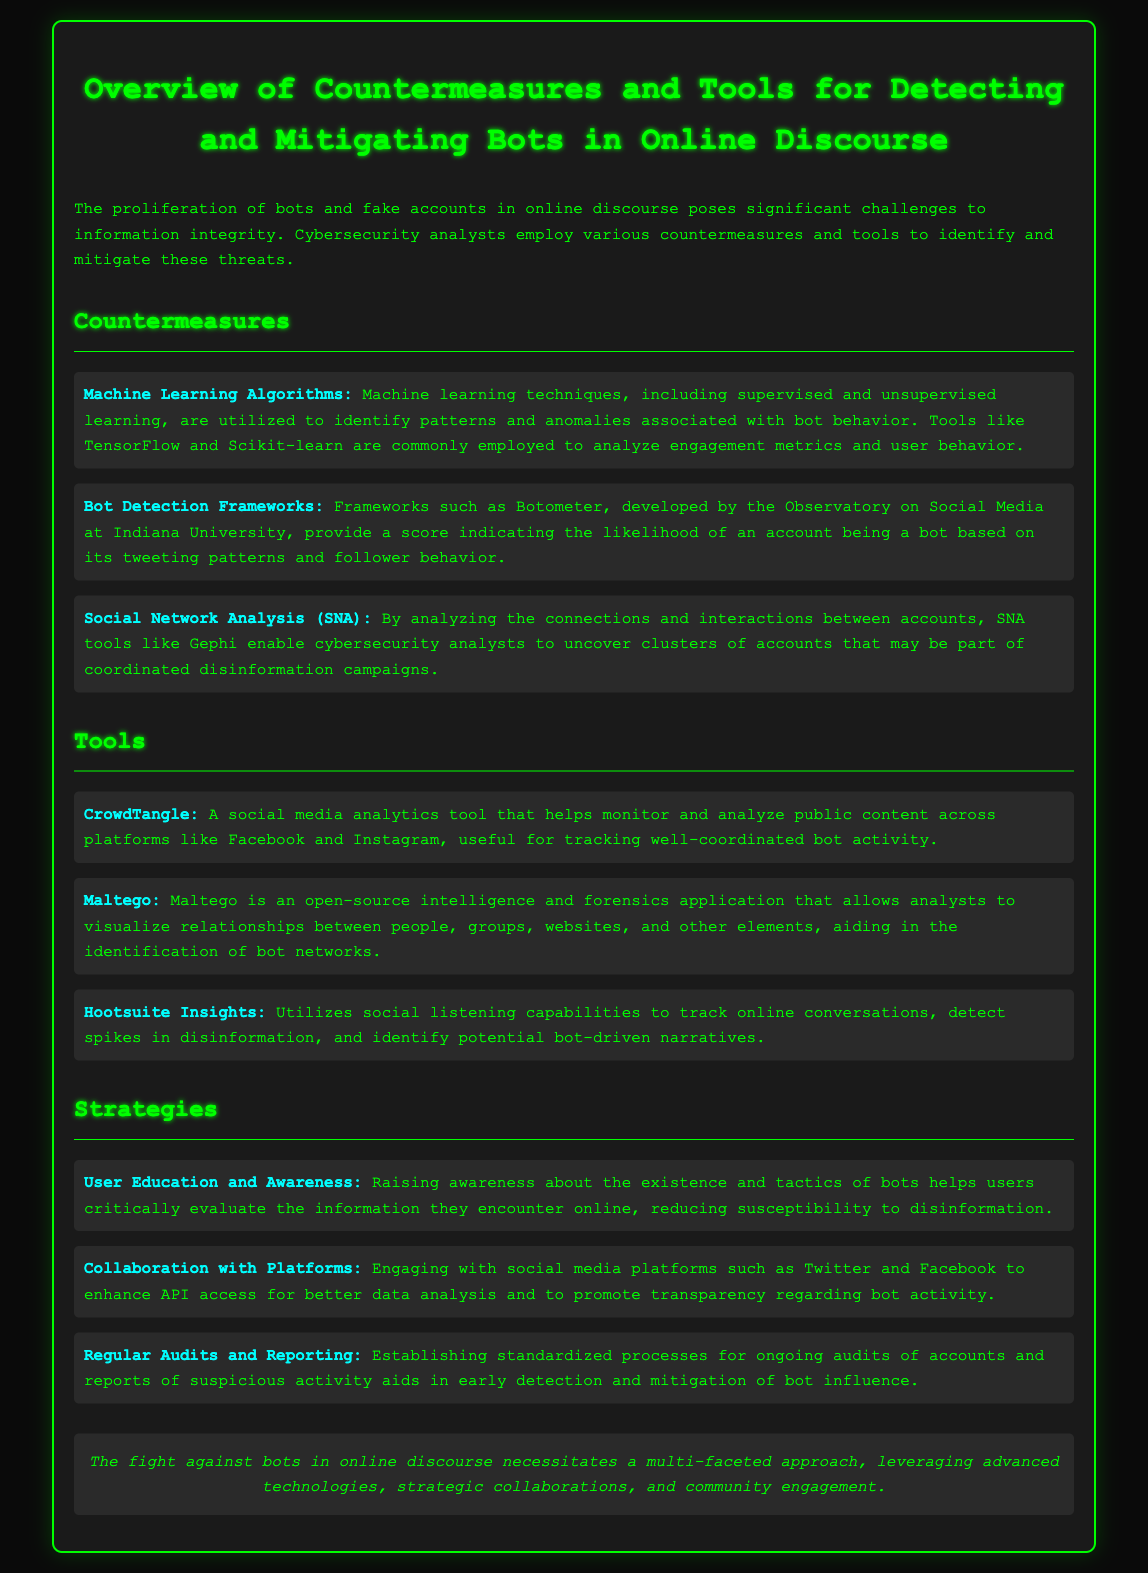What is the title of the document? The title of the document is provided in the header section of the rendered note.
Answer: Overview of Countermeasures and Tools for Detecting and Mitigating Bots in Online Discourse Which framework is developed by the Observatory on Social Media? The document mentions a specific framework associated with the Observatory, which is used for bot detection.
Answer: Botometer What tool is used for social media analytics? The document lists a tool specifically designed for analytics on social media platforms.
Answer: CrowdTangle What is one of the strategies mentioned for combating bots? The document outlines specific strategies employed to counter the influence of bots in online discourse.
Answer: User Education and Awareness How many main sections are present in the document? The document contains distinct sections that are clearly outlined with headings.
Answer: Three 